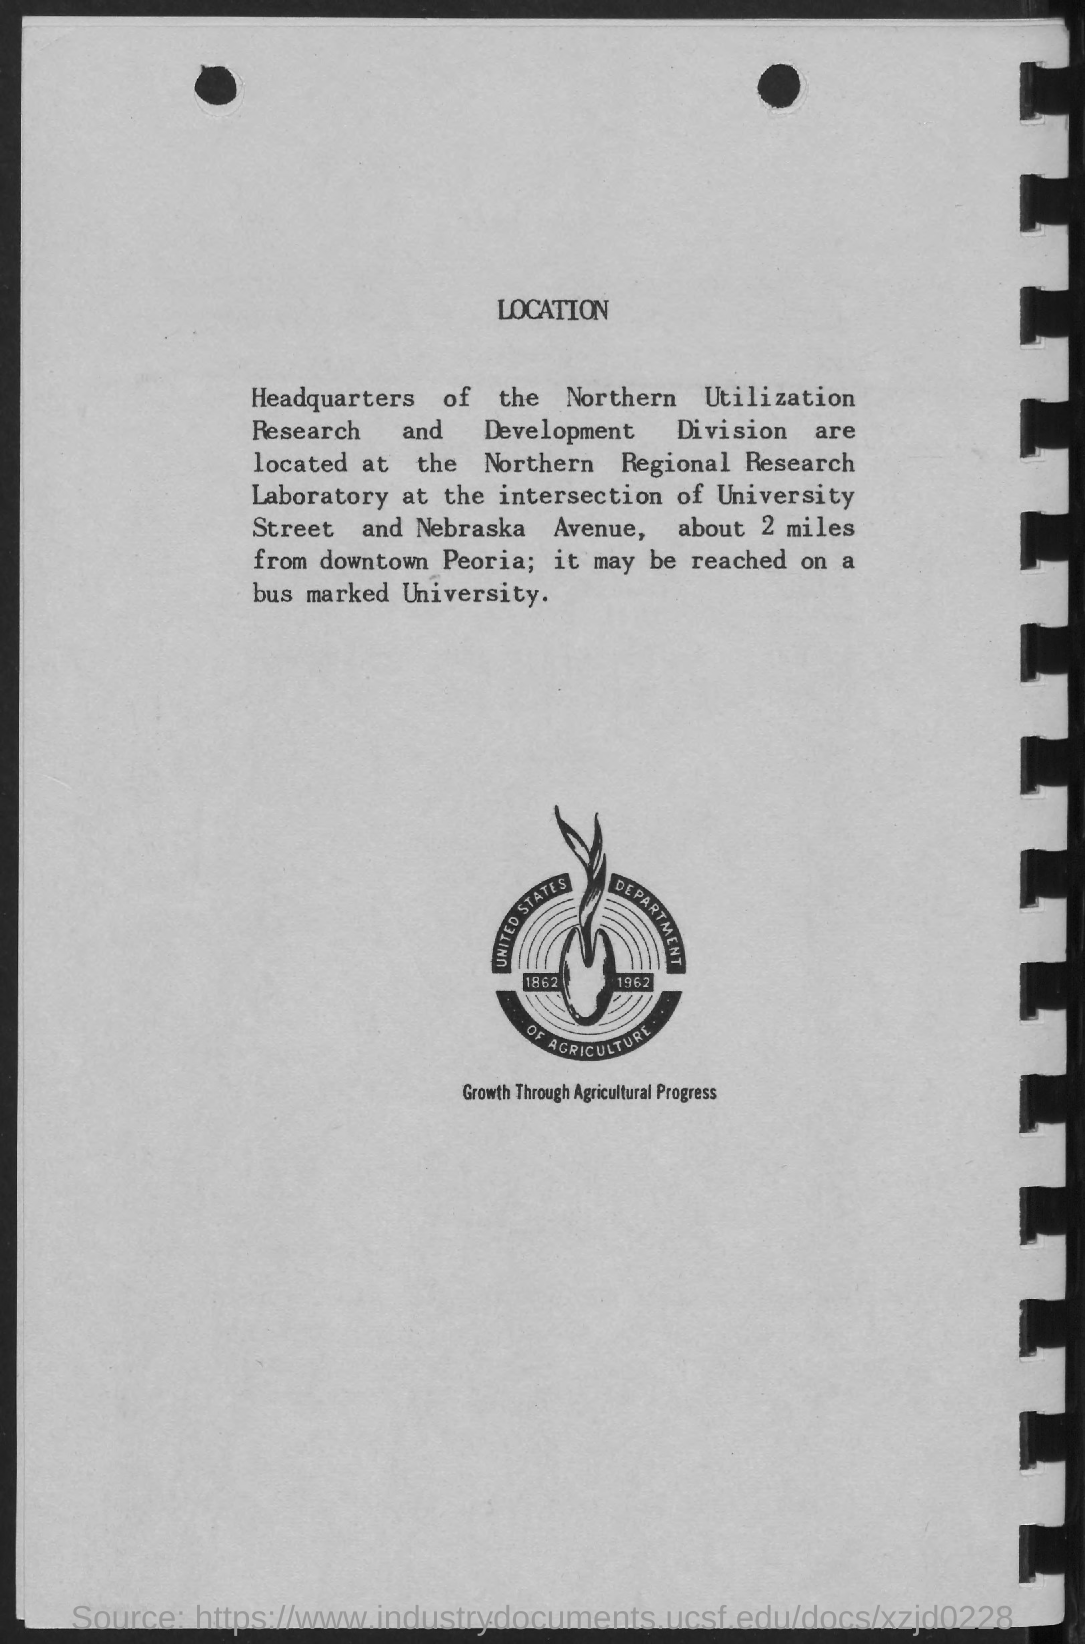Point out several critical features in this image. The title of the document is "What is the title of the document? Location.. The following image showcases the concept of growth through agricultural progress, highlighting various stages of crop development and the use of modern farming techniques to improve yields and promote sustainable agriculture. 